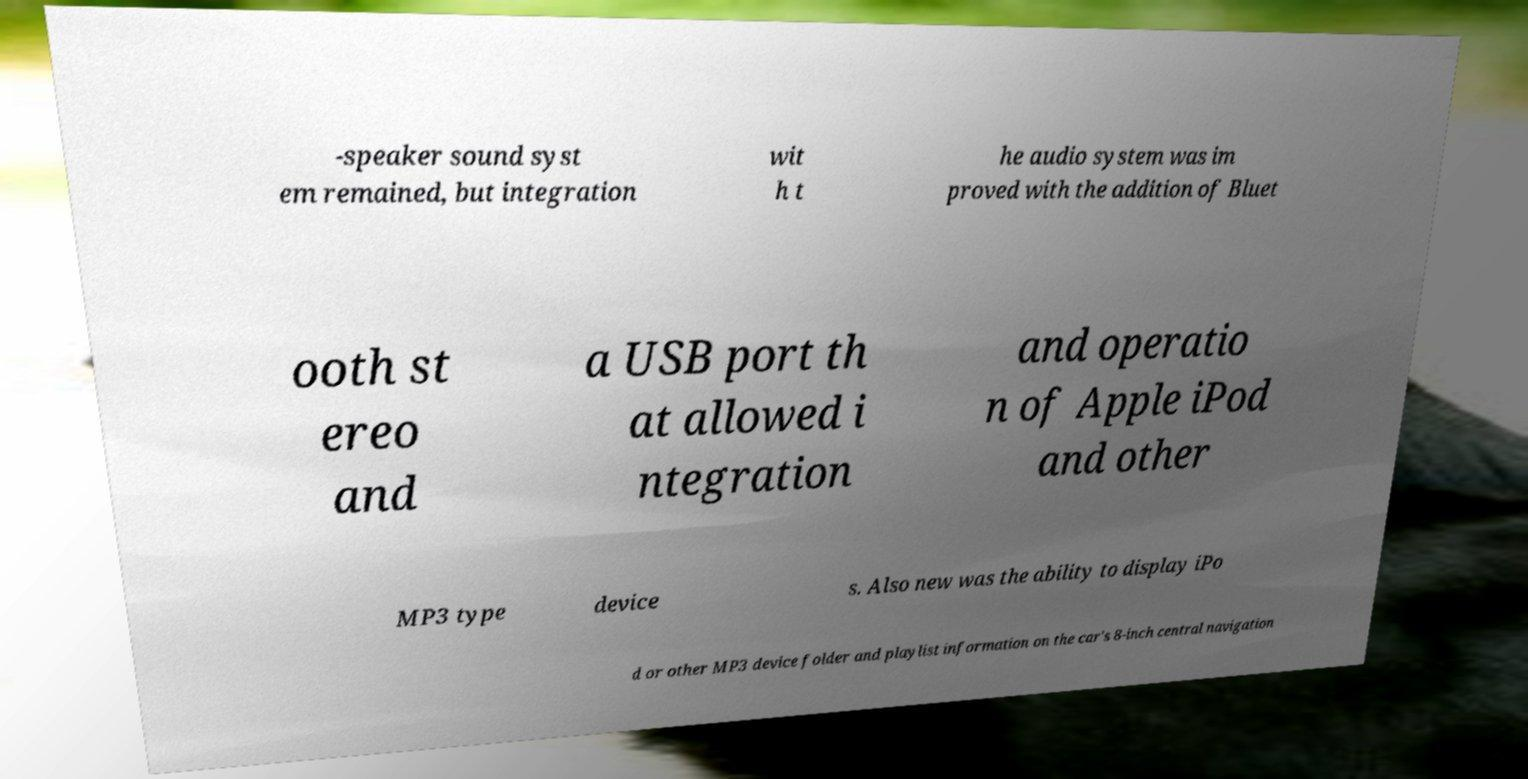Could you assist in decoding the text presented in this image and type it out clearly? -speaker sound syst em remained, but integration wit h t he audio system was im proved with the addition of Bluet ooth st ereo and a USB port th at allowed i ntegration and operatio n of Apple iPod and other MP3 type device s. Also new was the ability to display iPo d or other MP3 device folder and playlist information on the car's 8-inch central navigation 